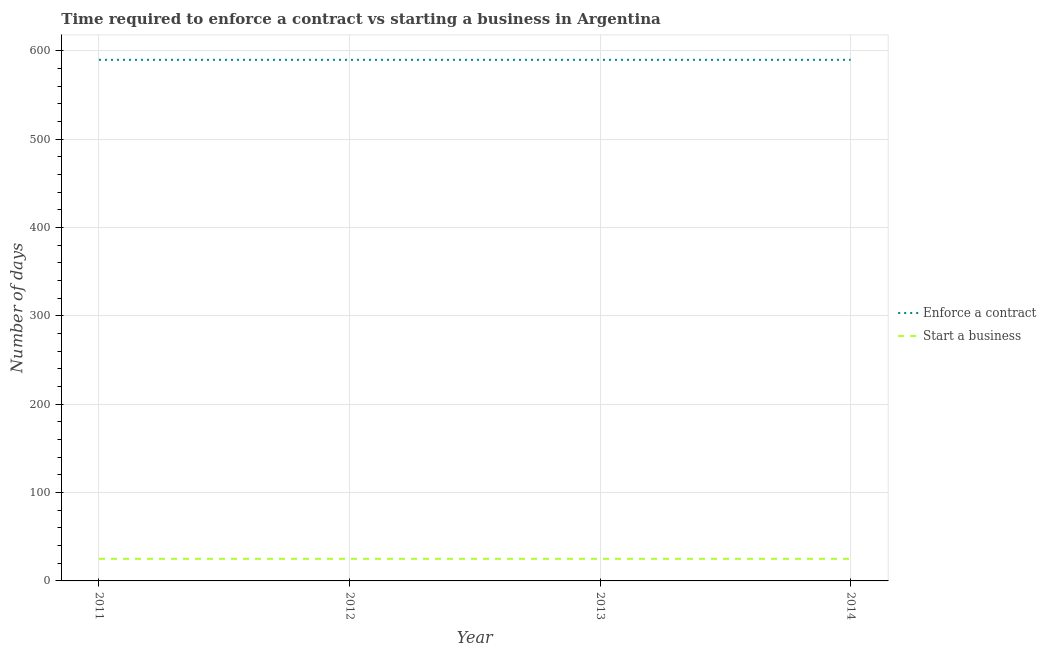Does the line corresponding to number of days to enforece a contract intersect with the line corresponding to number of days to start a business?
Make the answer very short. No. What is the number of days to start a business in 2012?
Make the answer very short. 25. Across all years, what is the minimum number of days to enforece a contract?
Keep it short and to the point. 590. What is the total number of days to start a business in the graph?
Give a very brief answer. 100. What is the difference between the number of days to enforece a contract in 2012 and that in 2014?
Offer a very short reply. 0. What is the difference between the number of days to start a business in 2013 and the number of days to enforece a contract in 2014?
Your answer should be compact. -565. What is the average number of days to start a business per year?
Your response must be concise. 25. In the year 2012, what is the difference between the number of days to enforece a contract and number of days to start a business?
Your answer should be very brief. 565. What is the ratio of the number of days to start a business in 2011 to that in 2012?
Keep it short and to the point. 1. Is the number of days to enforece a contract in 2011 less than that in 2013?
Your answer should be compact. No. Is the difference between the number of days to enforece a contract in 2011 and 2014 greater than the difference between the number of days to start a business in 2011 and 2014?
Provide a succinct answer. No. What is the difference between the highest and the lowest number of days to enforece a contract?
Provide a short and direct response. 0. In how many years, is the number of days to start a business greater than the average number of days to start a business taken over all years?
Offer a very short reply. 0. Does the number of days to start a business monotonically increase over the years?
Provide a succinct answer. No. Does the graph contain grids?
Your answer should be very brief. Yes. How many legend labels are there?
Ensure brevity in your answer.  2. How are the legend labels stacked?
Provide a succinct answer. Vertical. What is the title of the graph?
Your answer should be very brief. Time required to enforce a contract vs starting a business in Argentina. Does "From production" appear as one of the legend labels in the graph?
Offer a very short reply. No. What is the label or title of the X-axis?
Offer a terse response. Year. What is the label or title of the Y-axis?
Provide a short and direct response. Number of days. What is the Number of days of Enforce a contract in 2011?
Keep it short and to the point. 590. What is the Number of days in Enforce a contract in 2012?
Ensure brevity in your answer.  590. What is the Number of days of Enforce a contract in 2013?
Ensure brevity in your answer.  590. What is the Number of days in Start a business in 2013?
Your answer should be very brief. 25. What is the Number of days of Enforce a contract in 2014?
Your answer should be compact. 590. Across all years, what is the maximum Number of days of Enforce a contract?
Make the answer very short. 590. Across all years, what is the maximum Number of days in Start a business?
Keep it short and to the point. 25. Across all years, what is the minimum Number of days of Enforce a contract?
Ensure brevity in your answer.  590. Across all years, what is the minimum Number of days in Start a business?
Offer a terse response. 25. What is the total Number of days in Enforce a contract in the graph?
Offer a very short reply. 2360. What is the total Number of days of Start a business in the graph?
Keep it short and to the point. 100. What is the difference between the Number of days in Enforce a contract in 2011 and that in 2012?
Offer a very short reply. 0. What is the difference between the Number of days in Start a business in 2011 and that in 2012?
Offer a very short reply. 0. What is the difference between the Number of days of Start a business in 2012 and that in 2013?
Provide a succinct answer. 0. What is the difference between the Number of days in Start a business in 2012 and that in 2014?
Keep it short and to the point. 0. What is the difference between the Number of days of Enforce a contract in 2011 and the Number of days of Start a business in 2012?
Provide a succinct answer. 565. What is the difference between the Number of days in Enforce a contract in 2011 and the Number of days in Start a business in 2013?
Provide a succinct answer. 565. What is the difference between the Number of days of Enforce a contract in 2011 and the Number of days of Start a business in 2014?
Make the answer very short. 565. What is the difference between the Number of days in Enforce a contract in 2012 and the Number of days in Start a business in 2013?
Your answer should be very brief. 565. What is the difference between the Number of days of Enforce a contract in 2012 and the Number of days of Start a business in 2014?
Your answer should be very brief. 565. What is the difference between the Number of days of Enforce a contract in 2013 and the Number of days of Start a business in 2014?
Offer a very short reply. 565. What is the average Number of days of Enforce a contract per year?
Keep it short and to the point. 590. In the year 2011, what is the difference between the Number of days of Enforce a contract and Number of days of Start a business?
Your answer should be very brief. 565. In the year 2012, what is the difference between the Number of days in Enforce a contract and Number of days in Start a business?
Your response must be concise. 565. In the year 2013, what is the difference between the Number of days of Enforce a contract and Number of days of Start a business?
Offer a terse response. 565. In the year 2014, what is the difference between the Number of days of Enforce a contract and Number of days of Start a business?
Keep it short and to the point. 565. What is the ratio of the Number of days in Enforce a contract in 2011 to that in 2012?
Your response must be concise. 1. What is the ratio of the Number of days in Start a business in 2011 to that in 2012?
Provide a short and direct response. 1. What is the ratio of the Number of days of Enforce a contract in 2011 to that in 2013?
Your answer should be compact. 1. What is the ratio of the Number of days of Enforce a contract in 2011 to that in 2014?
Offer a terse response. 1. What is the ratio of the Number of days of Enforce a contract in 2012 to that in 2013?
Offer a terse response. 1. What is the ratio of the Number of days of Enforce a contract in 2012 to that in 2014?
Provide a short and direct response. 1. What is the ratio of the Number of days in Start a business in 2012 to that in 2014?
Your response must be concise. 1. What is the ratio of the Number of days in Enforce a contract in 2013 to that in 2014?
Provide a short and direct response. 1. What is the difference between the highest and the second highest Number of days of Enforce a contract?
Your response must be concise. 0. 